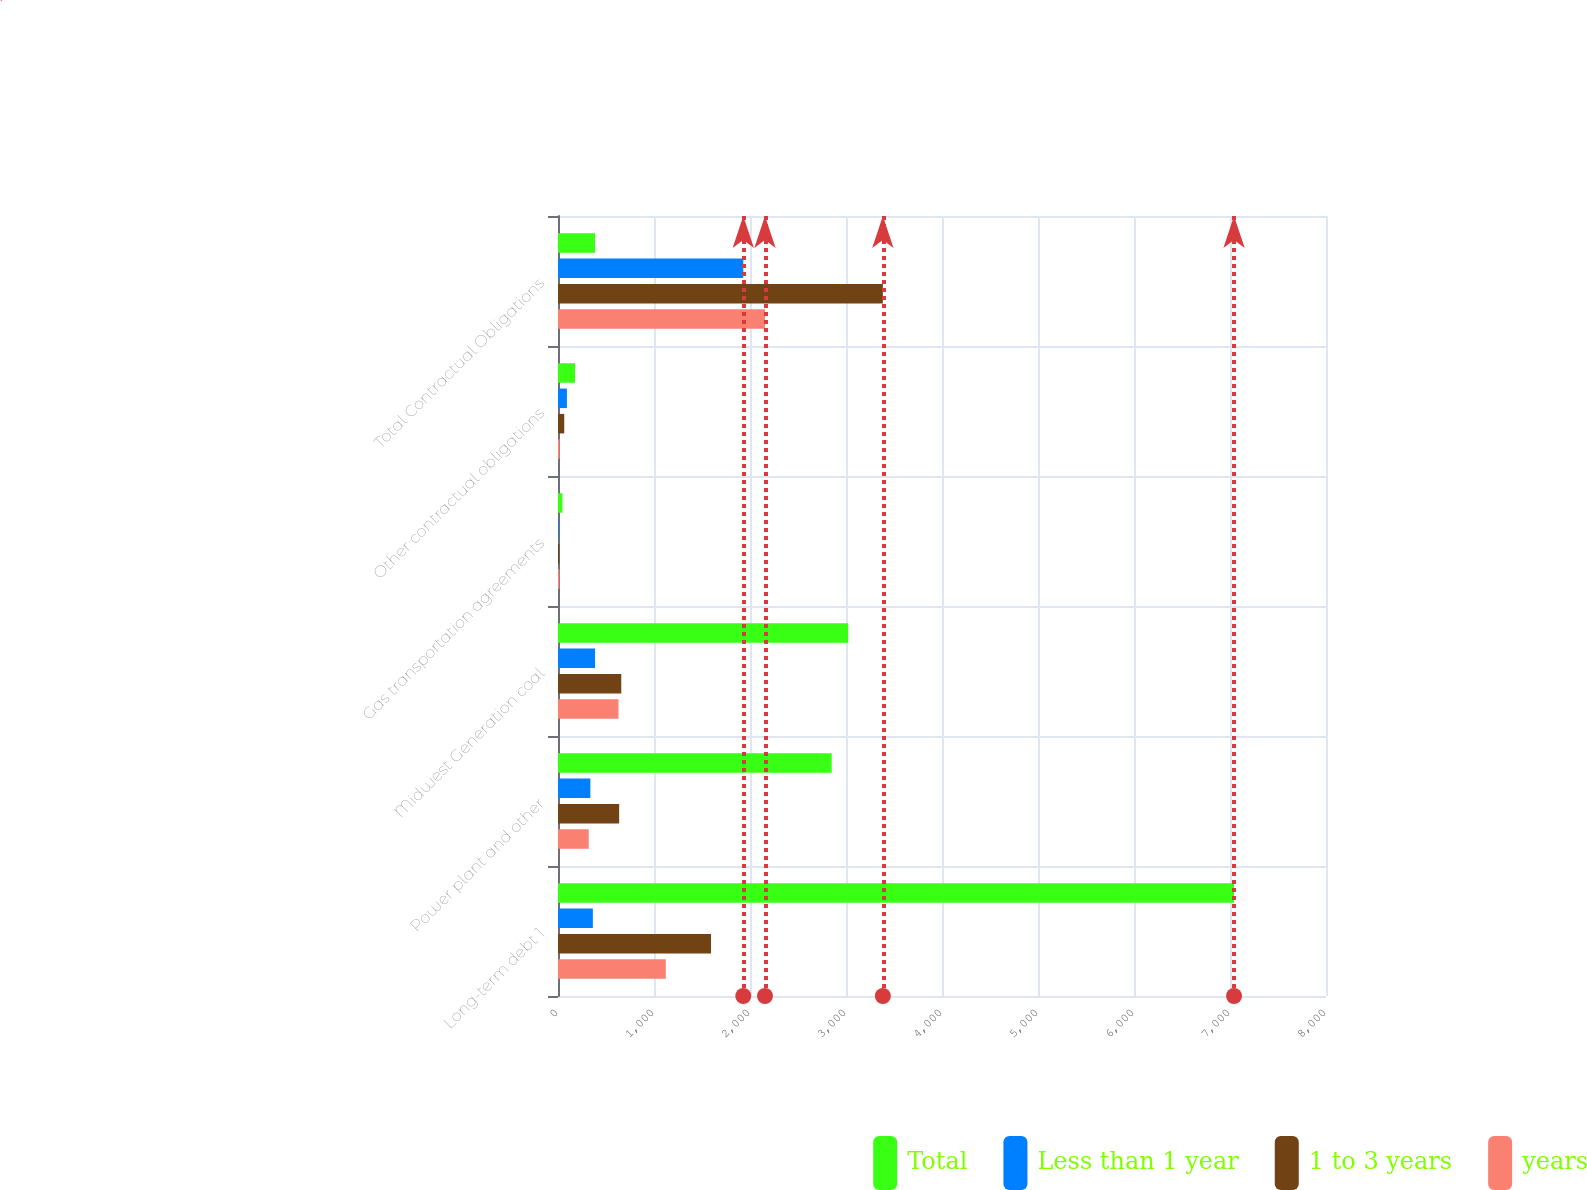Convert chart. <chart><loc_0><loc_0><loc_500><loc_500><stacked_bar_chart><ecel><fcel>Long-term debt 1<fcel>Power plant and other<fcel>Midwest Generation coal<fcel>Gas transportation agreements<fcel>Other contractual obligations<fcel>Total Contractual Obligations<nl><fcel>Total<fcel>7042<fcel>2851<fcel>3023<fcel>46<fcel>177<fcel>386<nl><fcel>Less than 1 year<fcel>363<fcel>337<fcel>386<fcel>7<fcel>93<fcel>1930<nl><fcel>1 to 3 years<fcel>1594<fcel>637<fcel>659<fcel>14<fcel>65<fcel>3384<nl><fcel>years<fcel>1123<fcel>320<fcel>630<fcel>15<fcel>17<fcel>2156<nl></chart> 